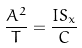<formula> <loc_0><loc_0><loc_500><loc_500>\frac { A ^ { 2 } } { T } = \frac { I S _ { x } } { C }</formula> 